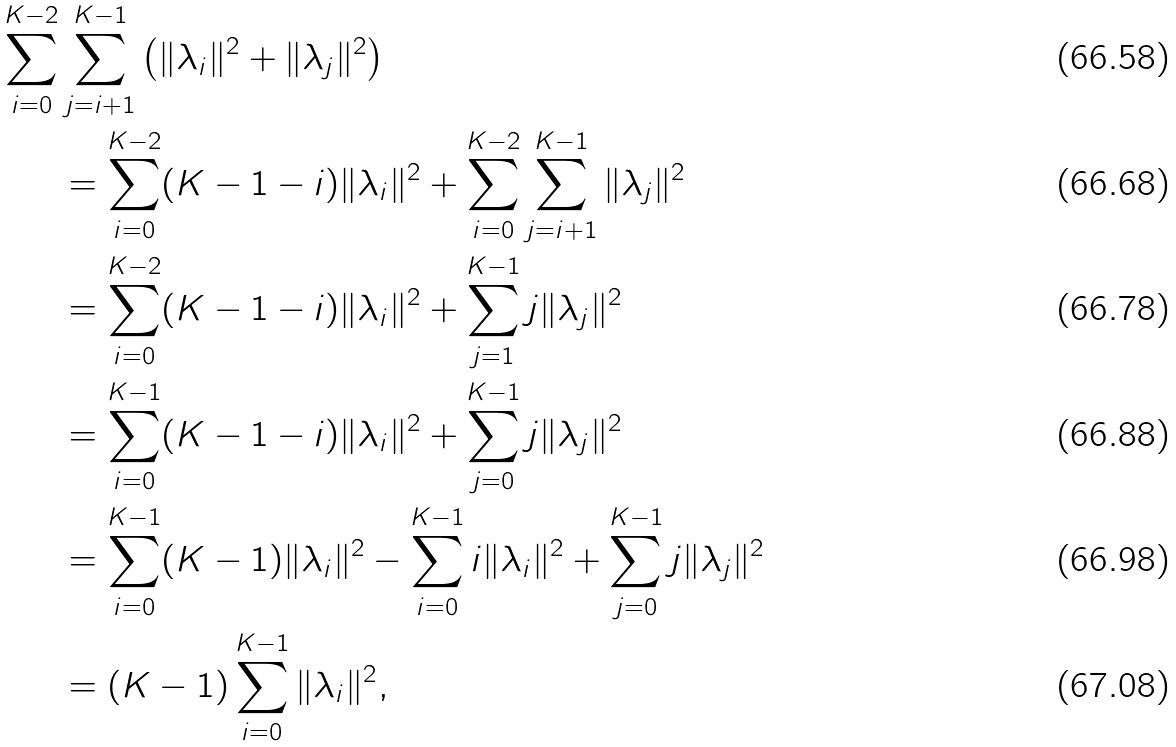Convert formula to latex. <formula><loc_0><loc_0><loc_500><loc_500>\sum _ { i = 0 } ^ { K - 2 } & \sum _ { j = i + 1 } ^ { K - 1 } \left ( \| \lambda _ { i } \| ^ { 2 } + \| \lambda _ { j } \| ^ { 2 } \right ) \\ & = \sum _ { i = 0 } ^ { K - 2 } ( K - 1 - i ) \| \lambda _ { i } \| ^ { 2 } + \sum _ { i = 0 } ^ { K - 2 } \sum _ { j = i + 1 } ^ { K - 1 } \| \lambda _ { j } \| ^ { 2 } \\ & = \sum _ { i = 0 } ^ { K - 2 } ( K - 1 - i ) \| \lambda _ { i } \| ^ { 2 } + \sum _ { j = 1 } ^ { K - 1 } j \| \lambda _ { j } \| ^ { 2 } \\ & = \sum _ { i = 0 } ^ { K - 1 } ( K - 1 - i ) \| \lambda _ { i } \| ^ { 2 } + \sum _ { j = 0 } ^ { K - 1 } j \| \lambda _ { j } \| ^ { 2 } \\ & = \sum _ { i = 0 } ^ { K - 1 } ( K - 1 ) \| \lambda _ { i } \| ^ { 2 } - \sum _ { i = 0 } ^ { K - 1 } i \| \lambda _ { i } \| ^ { 2 } + \sum _ { j = 0 } ^ { K - 1 } j \| \lambda _ { j } \| ^ { 2 } \\ & = ( K - 1 ) \sum _ { i = 0 } ^ { K - 1 } \| \lambda _ { i } \| ^ { 2 } ,</formula> 